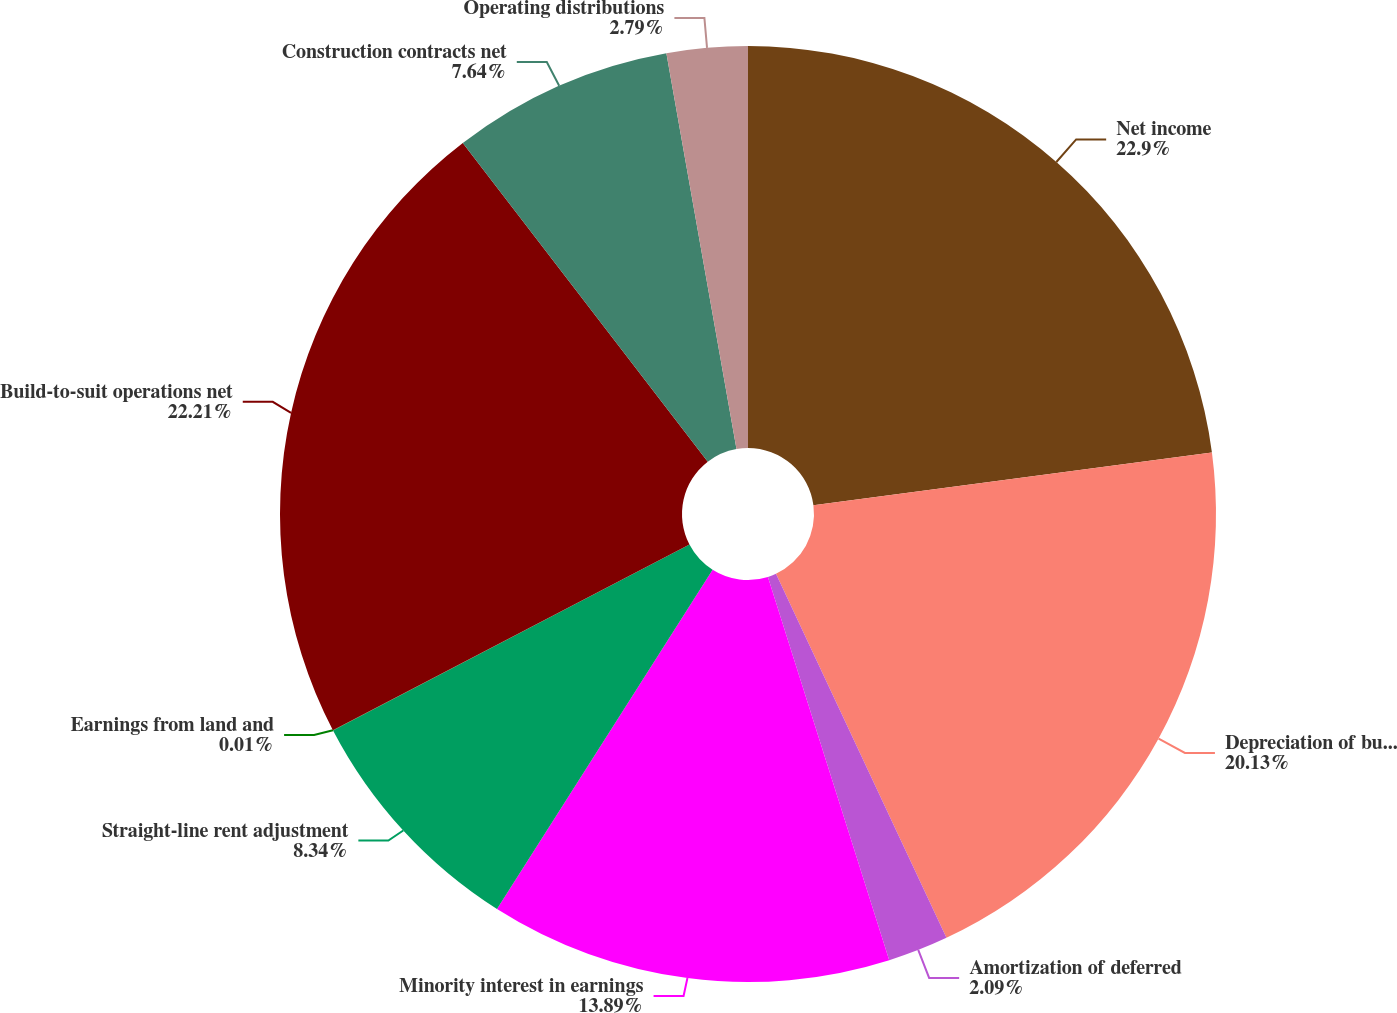Convert chart. <chart><loc_0><loc_0><loc_500><loc_500><pie_chart><fcel>Net income<fcel>Depreciation of buildings and<fcel>Amortization of deferred<fcel>Minority interest in earnings<fcel>Straight-line rent adjustment<fcel>Earnings from land and<fcel>Build-to-suit operations net<fcel>Construction contracts net<fcel>Operating distributions<nl><fcel>22.9%<fcel>20.13%<fcel>2.09%<fcel>13.89%<fcel>8.34%<fcel>0.01%<fcel>22.21%<fcel>7.64%<fcel>2.79%<nl></chart> 